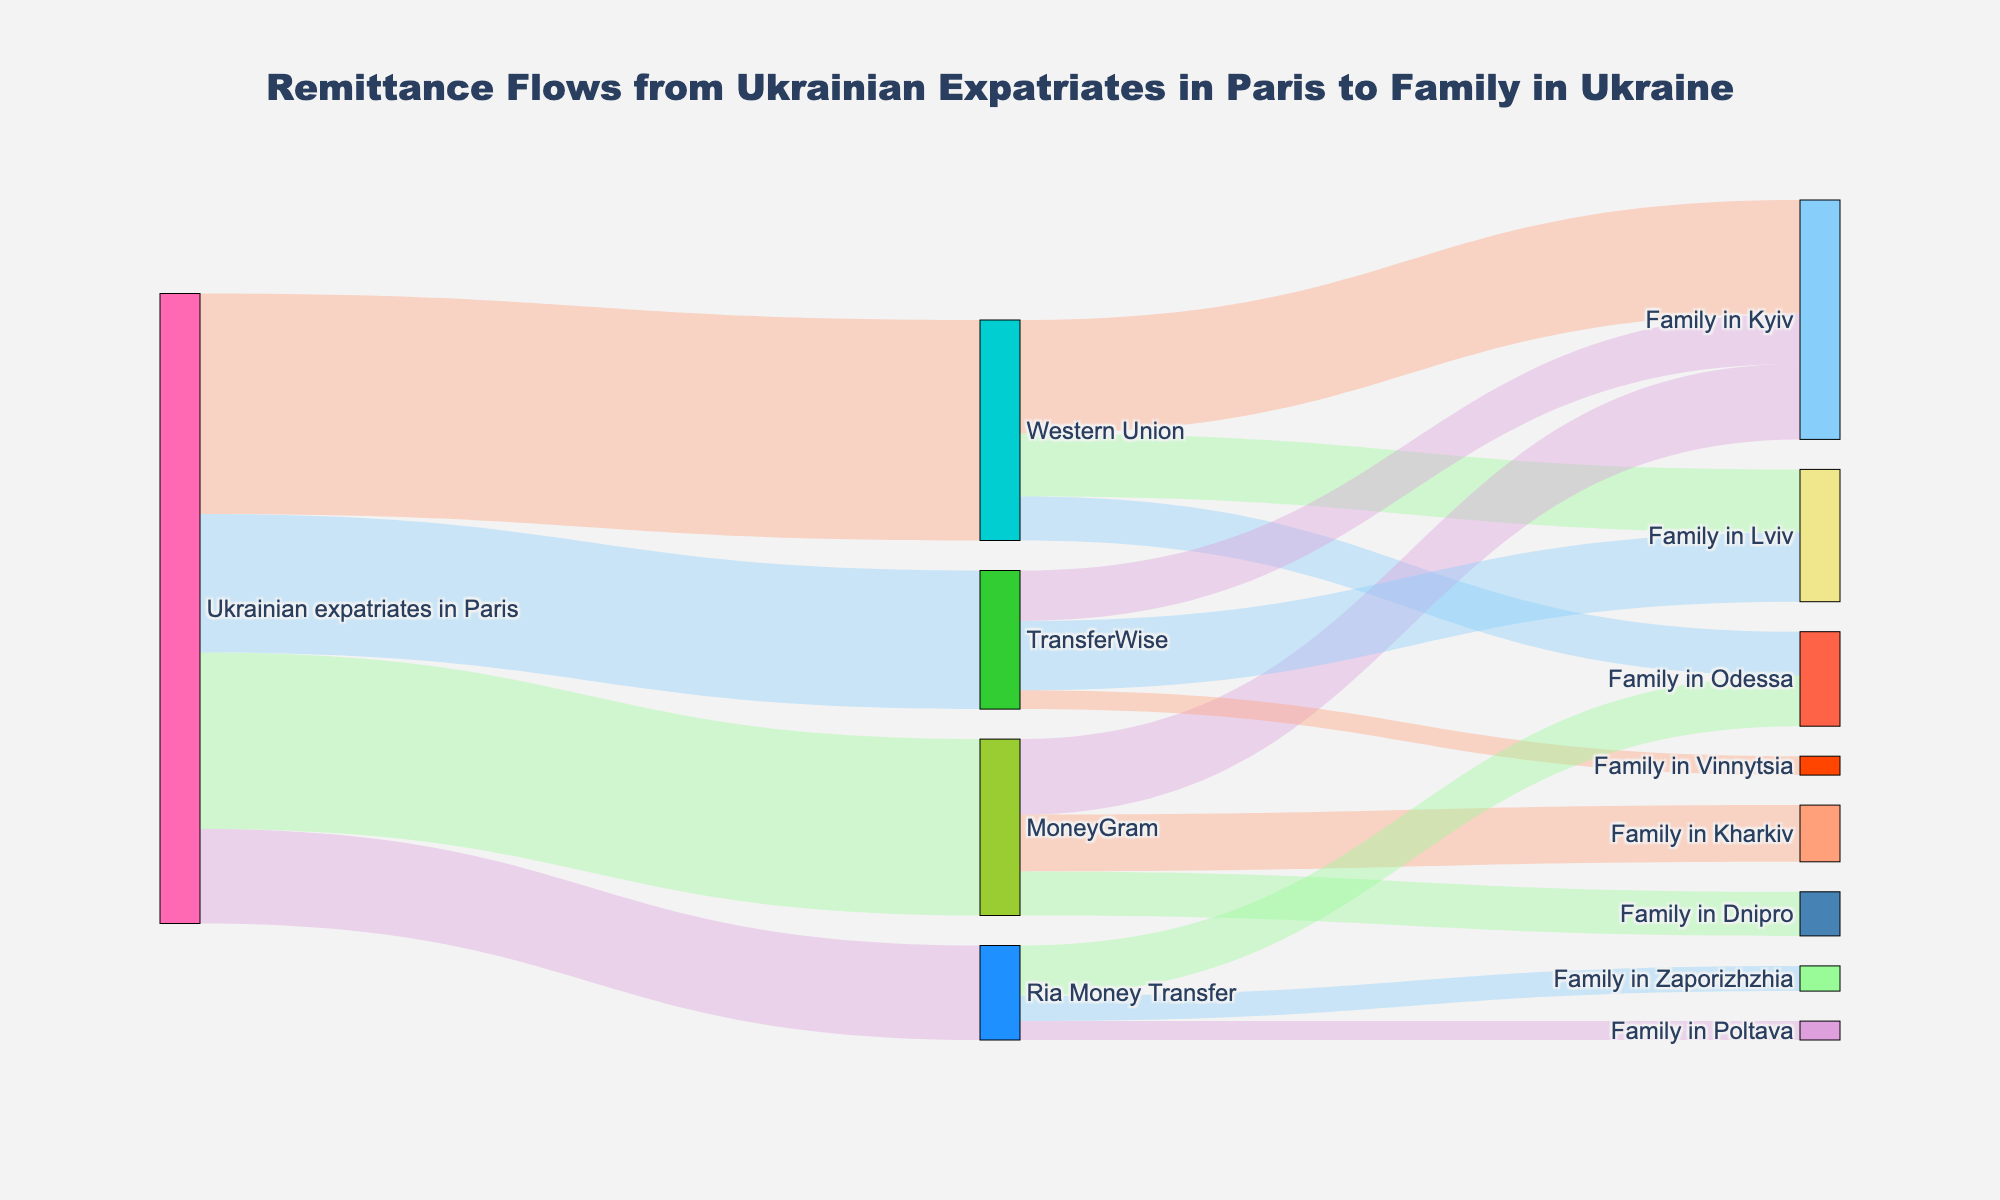How many total remittance channels are shown in the diagram? The remittance channels are represented by the unique nodes in the diagram that show different services used by Ukrainian expatriates in Paris to send money. These services are Western Union, MoneyGram, TransferWise, and Ria Money Transfer.
Answer: 4 Which service receives the highest amount of remittances from Ukrainian expatriates in Paris? Look at the first set of connections from 'Ukrainian expatriates in Paris' to the remittance services such as Western Union, MoneyGram, TransferWise, and Ria Money Transfer. Western Union corresponds to the highest value of 3,500,000.
Answer: Western Union What is the total amount of remittances received by families in Kyiv? To find the total amount, sum the values directed towards 'Family in Kyiv' from all remittance services: Western Union (1,800,000) + MoneyGram (1,200,000) + TransferWise (800,000). The sum is 3,800,000.
Answer: 3,800,000 Compare the remittances received by families in Odessa from Western Union and Ria Money Transfer. Which service is higher and by how much? For 'Family in Odessa', Western Union sends 700,000 while Ria Money Transfer sends 800,000. Subtract the values to find the difference: 800,000 - 700,000 = 100,000. Ria Money Transfer is higher by 100,000.
Answer: Ria Money Transfer, 100,000 What is the total amount of remittances directed towards families from all sources? Sum all the values flowing into family nodes: Kyiv (1800k + 1200k + 800k) + Lviv (1000k + 1100k) + Odessa (700k + 800k) + Kharkiv (900k) + Dnipro (700k) + Vinnytsia (300k) + Zaporizhzhia (400k) + Poltava (300k). The total is 10,000,000.
Answer: 10,000,000 Which family location receives the highest remittances, and how much is it? Compare the total remittances directed to each family location. Kyiv receives: Western Union (1,800,000) + MoneyGram (1,200,000) + TransferWise (800,000) = 3,800,000, which is the highest.
Answer: Kyiv, 3,800,000 How does the amount sent by MoneyGram compare to that sent by TransferWise? Compare the total amounts sent by each: MoneyGram (2,800,000) and TransferWise (2,200,000). MoneyGram sends more.
Answer: MoneyGram sends more What percentage of the total remittances does TransferWise handle? Total remittances are 10,000,000. TransferWise's remittances total 2,200,000. Calculate the percentage: (2,200,000 / 10,000,000) * 100 = 22%.
Answer: 22% Which node is associated with the fewest connections, and how many does it have? Count the links for each node. 'Family in Poltava' has only 1 connection from Ria Money Transfer, which is the fewest.
Answer: Family in Poltava, 1 